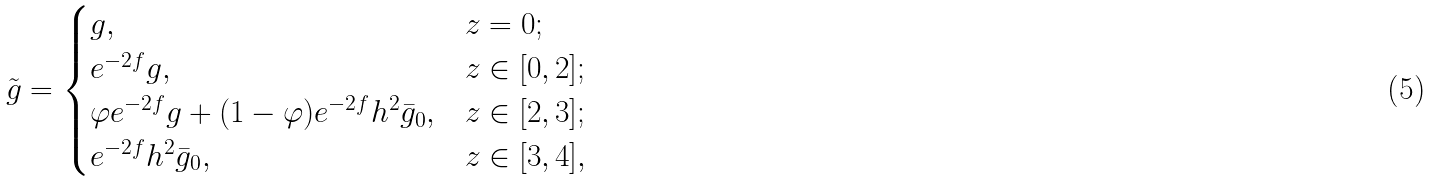<formula> <loc_0><loc_0><loc_500><loc_500>\tilde { g } = \begin{cases} g , & { z = 0 ; } \\ e ^ { - 2 f } g , & { z \in [ 0 , 2 ] ; } \\ \varphi e ^ { - 2 f } g + ( 1 - \varphi ) e ^ { - 2 f } h ^ { 2 } \bar { g } _ { 0 } , & { z \in [ 2 , 3 ] ; } \\ e ^ { - 2 f } h ^ { 2 } \bar { g } _ { 0 } , & { z \in [ 3 , 4 ] , } \end{cases}</formula> 